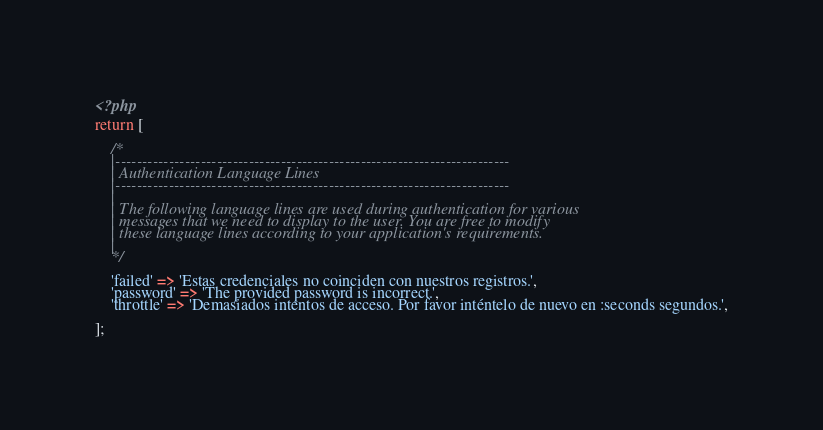Convert code to text. <code><loc_0><loc_0><loc_500><loc_500><_PHP_><?php

return [

    /*
    |--------------------------------------------------------------------------
    | Authentication Language Lines
    |--------------------------------------------------------------------------
    |
    | The following language lines are used during authentication for various
    | messages that we need to display to the user. You are free to modify
    | these language lines according to your application's requirements.
    |
    */

    'failed' => 'Estas credenciales no coinciden con nuestros registros.',
    'password' => 'The provided password is incorrect.',  
    'throttle' => 'Demasiados intentos de acceso. Por favor inténtelo de nuevo en :seconds segundos.',

];
</code> 